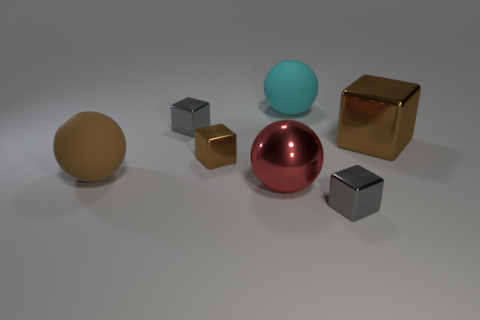Which object stands out the most to you, and why? The large shiny red ball stands out the most because of its vibrant color and highly reflective surface, which contrasts with the subdued colors and textures of the surrounding objects. 